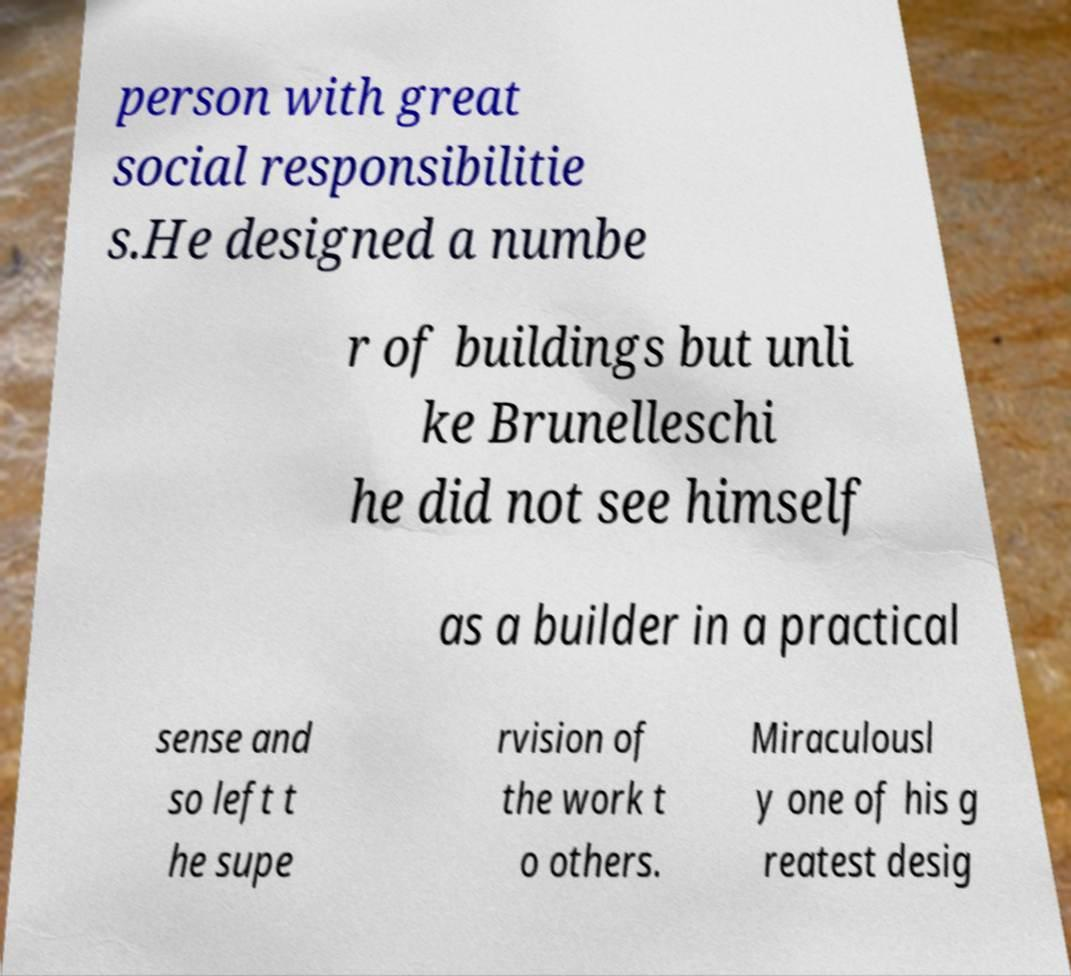There's text embedded in this image that I need extracted. Can you transcribe it verbatim? person with great social responsibilitie s.He designed a numbe r of buildings but unli ke Brunelleschi he did not see himself as a builder in a practical sense and so left t he supe rvision of the work t o others. Miraculousl y one of his g reatest desig 